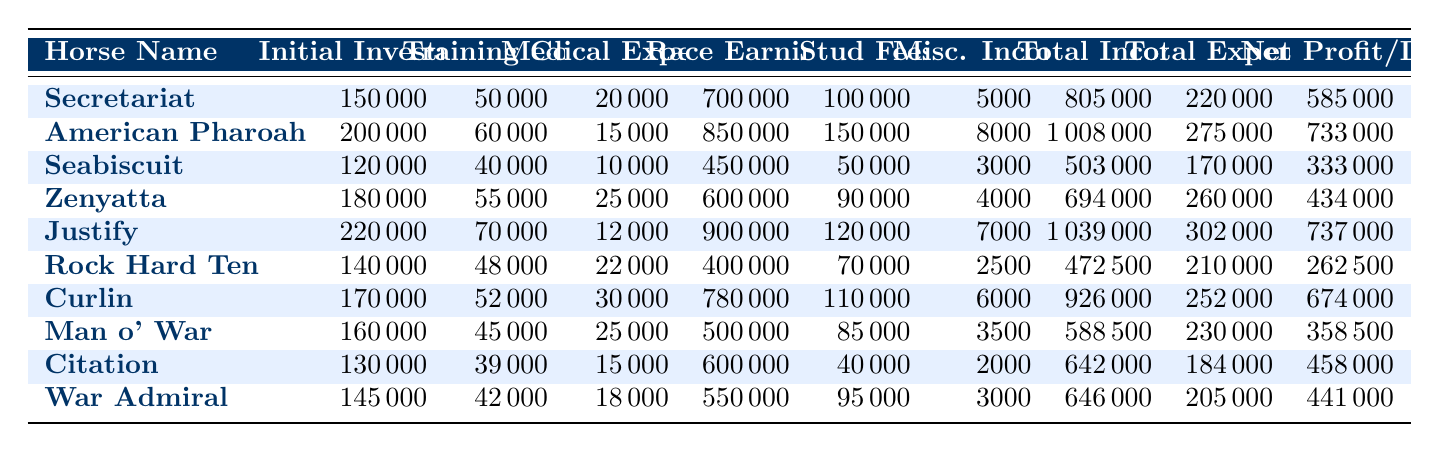What horse had the highest race earnings? Looking at the "Race Earnings" column, American Pharoah has the highest value at 850000, which is greater than any other horse's race earnings.
Answer: American Pharoah What is the total income for Zenyatta? The "Total Income" for Zenyatta is listed as 694000 according to the table, which corresponds directly to the data provided.
Answer: 694000 Which horse had the largest net profit/loss, and what is that amount? In the "Net Profit/Loss" column, Justify shows the largest net profit at 737000 when compared with all other horses' profits or losses.
Answer: Justify: 737000 What are the total expenses for Secretariat and Seabiscuit combined? The total expenses are found in their respective rows: Secretariat has 220000 and Seabiscuit has 170000. Summing these gives 220000 + 170000 = 390000.
Answer: 390000 Is it true that Curlin had higher training costs than War Admiral? Reviewing the "Training Costs" for both horses, Curlin has 52000 while War Admiral has 42000, confirming that Curlin's training cost is indeed higher.
Answer: Yes Which horse has the lowest initial investment, and how much is it? The "Initial Investment" column indicates that Seabiscuit has the lowest value at 120000 when reviewing all horse investments listed.
Answer: Seabiscuit: 120000 If we average the net profit/loss of all horses, what roughly is that average value? To find the average, first sum the net profit/loss values: 585000 + 733000 + 333000 + 434000 + 737000 + 262500 + 674000 + 358500 + 458000 + 441000 = 4513000. Dividing this by 10 (the number of horses) gives 451300. Therefore, the average net profit/loss is approximately 451300.
Answer: 451300 How much more did American Pharoah earn than Zenyatta in total income? From the "Total Income" column, American Pharoah has 1008000 and Zenyatta has 694000. The difference is 1008000 - 694000 = 314000, indicating American Pharoah earned more.
Answer: 314000 What percentage of the total income did War Admiral gain from race earnings? War Admiral's "Race Earnings" are 550000, and the total income is 646000. The formula is (550000 / 646000) * 100. This calculates to approximately 85.2%, so War Admiral earned about that percentage from race earnings.
Answer: 85.2% 